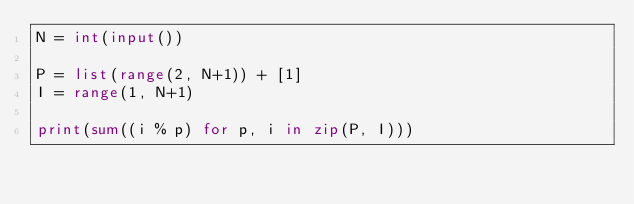Convert code to text. <code><loc_0><loc_0><loc_500><loc_500><_Python_>N = int(input())

P = list(range(2, N+1)) + [1]
I = range(1, N+1)

print(sum((i % p) for p, i in zip(P, I)))</code> 